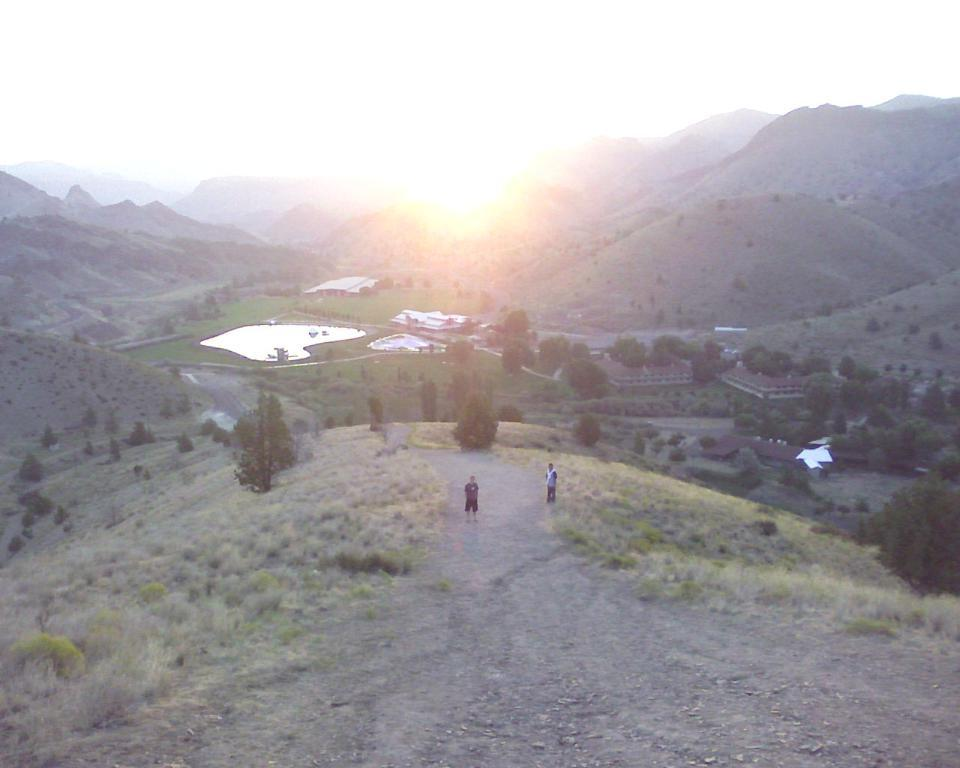What can be seen in the image? There are people standing in the image, along with grass, trees, buildings, water, hills, and the sky. Can you describe the environment in the image? The environment in the image includes grass, trees, water, and hills, suggesting a natural setting. There are also buildings, indicating an urban or suburban area. What is the weather like in the image? The sky is visible in the background of the image, but there is no specific information about the weather. How many people are in the image? There are people standing in the image, but the exact number is not specified. What type of honey can be seen dripping from the trees in the image? There is no honey present in the image; it features people, grass, trees, buildings, water, hills, and the sky. 